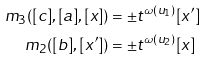Convert formula to latex. <formula><loc_0><loc_0><loc_500><loc_500>m _ { 3 } ( [ c ] , [ a ] , [ x ] ) & = \pm t ^ { \omega ( u _ { 1 } ) } [ x ^ { \prime } ] \\ m _ { 2 } ( [ b ] , [ x ^ { \prime } ] ) & = \pm t ^ { \omega ( u _ { 2 } ) } [ x ]</formula> 